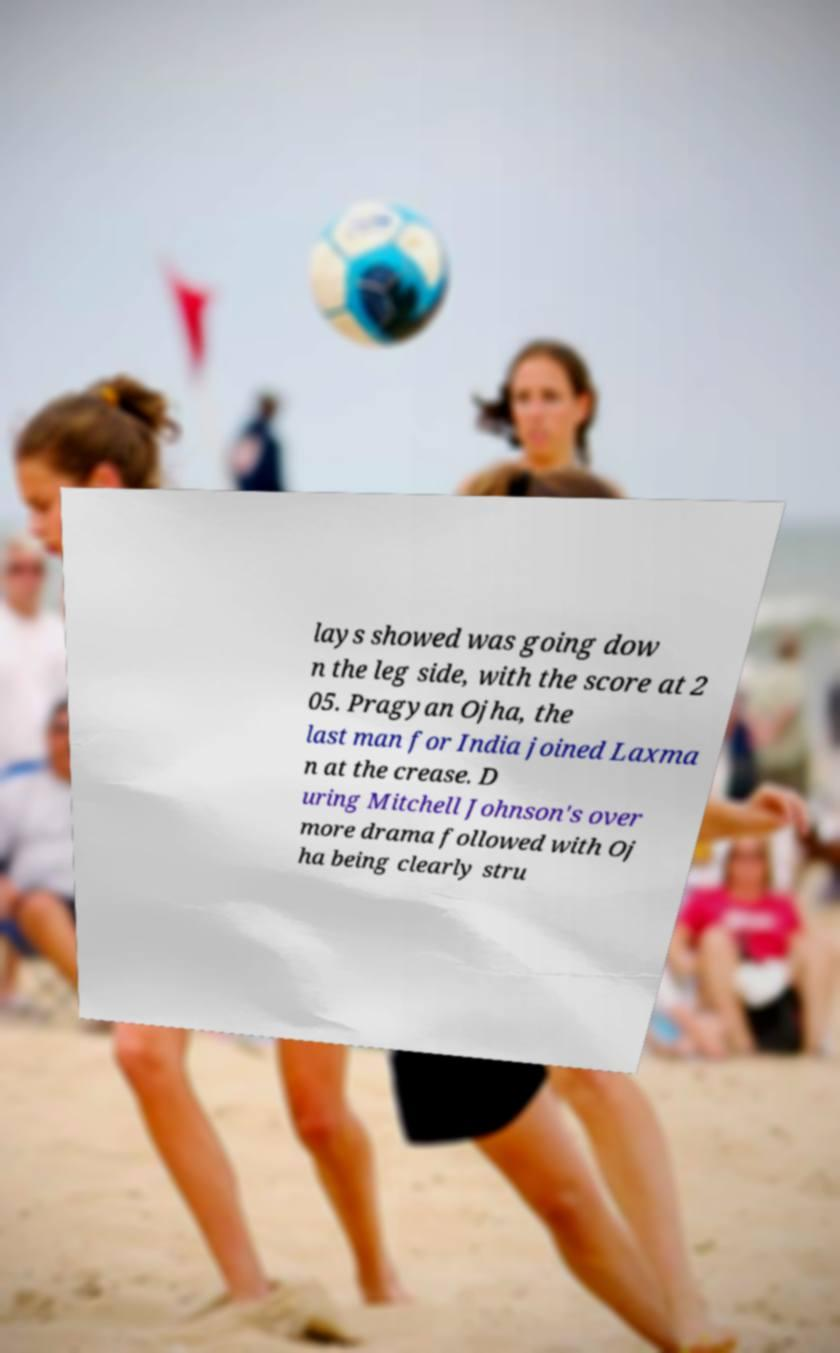I need the written content from this picture converted into text. Can you do that? lays showed was going dow n the leg side, with the score at 2 05. Pragyan Ojha, the last man for India joined Laxma n at the crease. D uring Mitchell Johnson's over more drama followed with Oj ha being clearly stru 